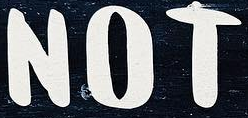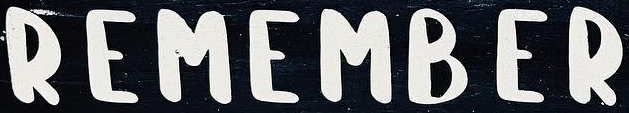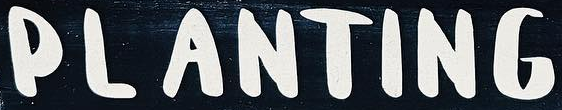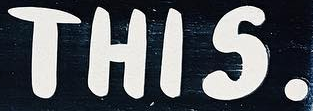What text appears in these images from left to right, separated by a semicolon? NOT; REMAMBER; PLANTING; THIS. 